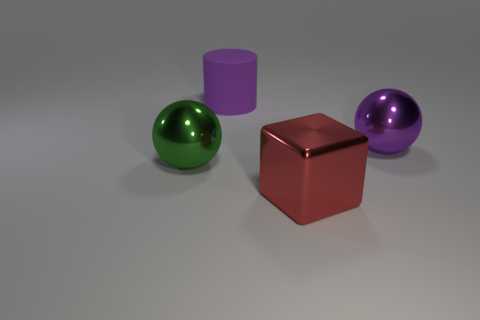There is a big sphere that is the same color as the cylinder; what material is it? metal 